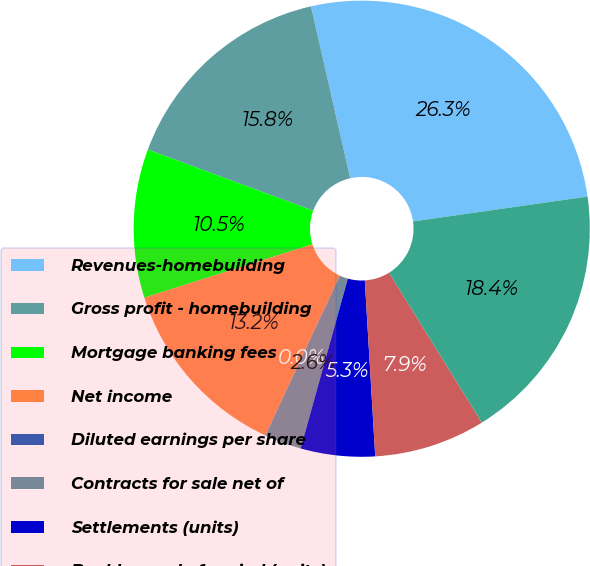Convert chart. <chart><loc_0><loc_0><loc_500><loc_500><pie_chart><fcel>Revenues-homebuilding<fcel>Gross profit - homebuilding<fcel>Mortgage banking fees<fcel>Net income<fcel>Diluted earnings per share<fcel>Contracts for sale net of<fcel>Settlements (units)<fcel>Backlog end of period (units)<fcel>Loans closed<nl><fcel>26.32%<fcel>15.79%<fcel>10.53%<fcel>13.16%<fcel>0.0%<fcel>2.63%<fcel>5.26%<fcel>7.89%<fcel>18.42%<nl></chart> 